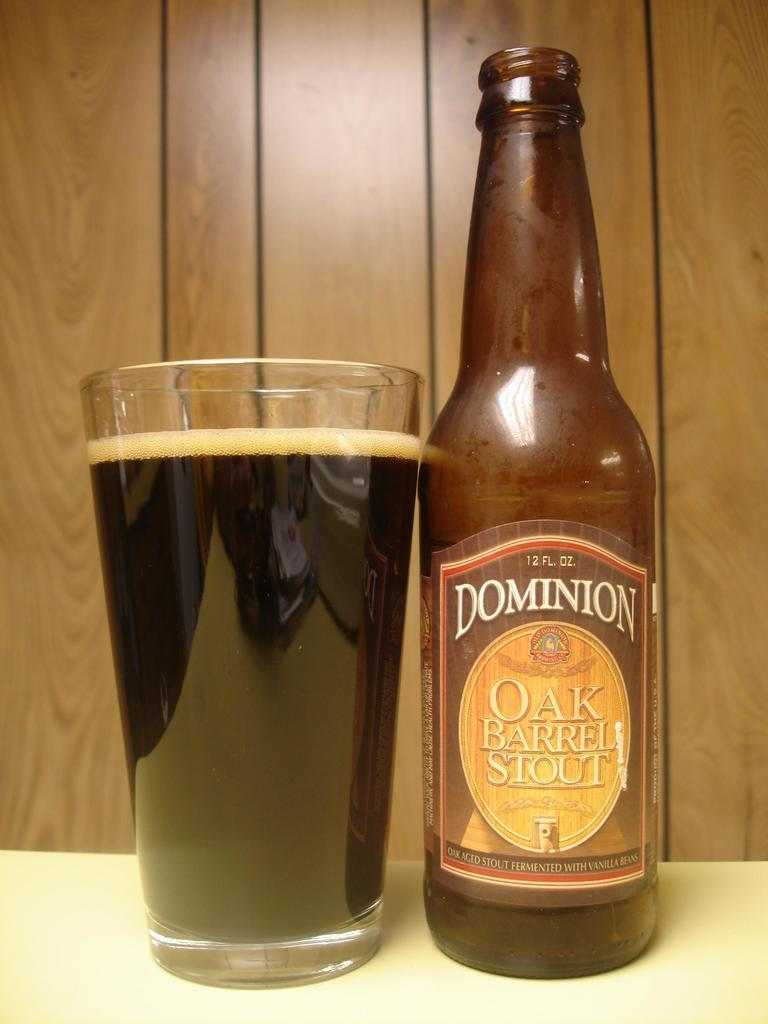What is one object visible in the image? There is a bottle in the image. What is another object visible in the image? There is a glass in the image. How many bikes are parked next to the glass in the image? There are no bikes present in the image. What day of the week is it in the image? The day of the week is not visible or mentioned in the image. 